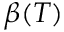Convert formula to latex. <formula><loc_0><loc_0><loc_500><loc_500>\beta ( T )</formula> 